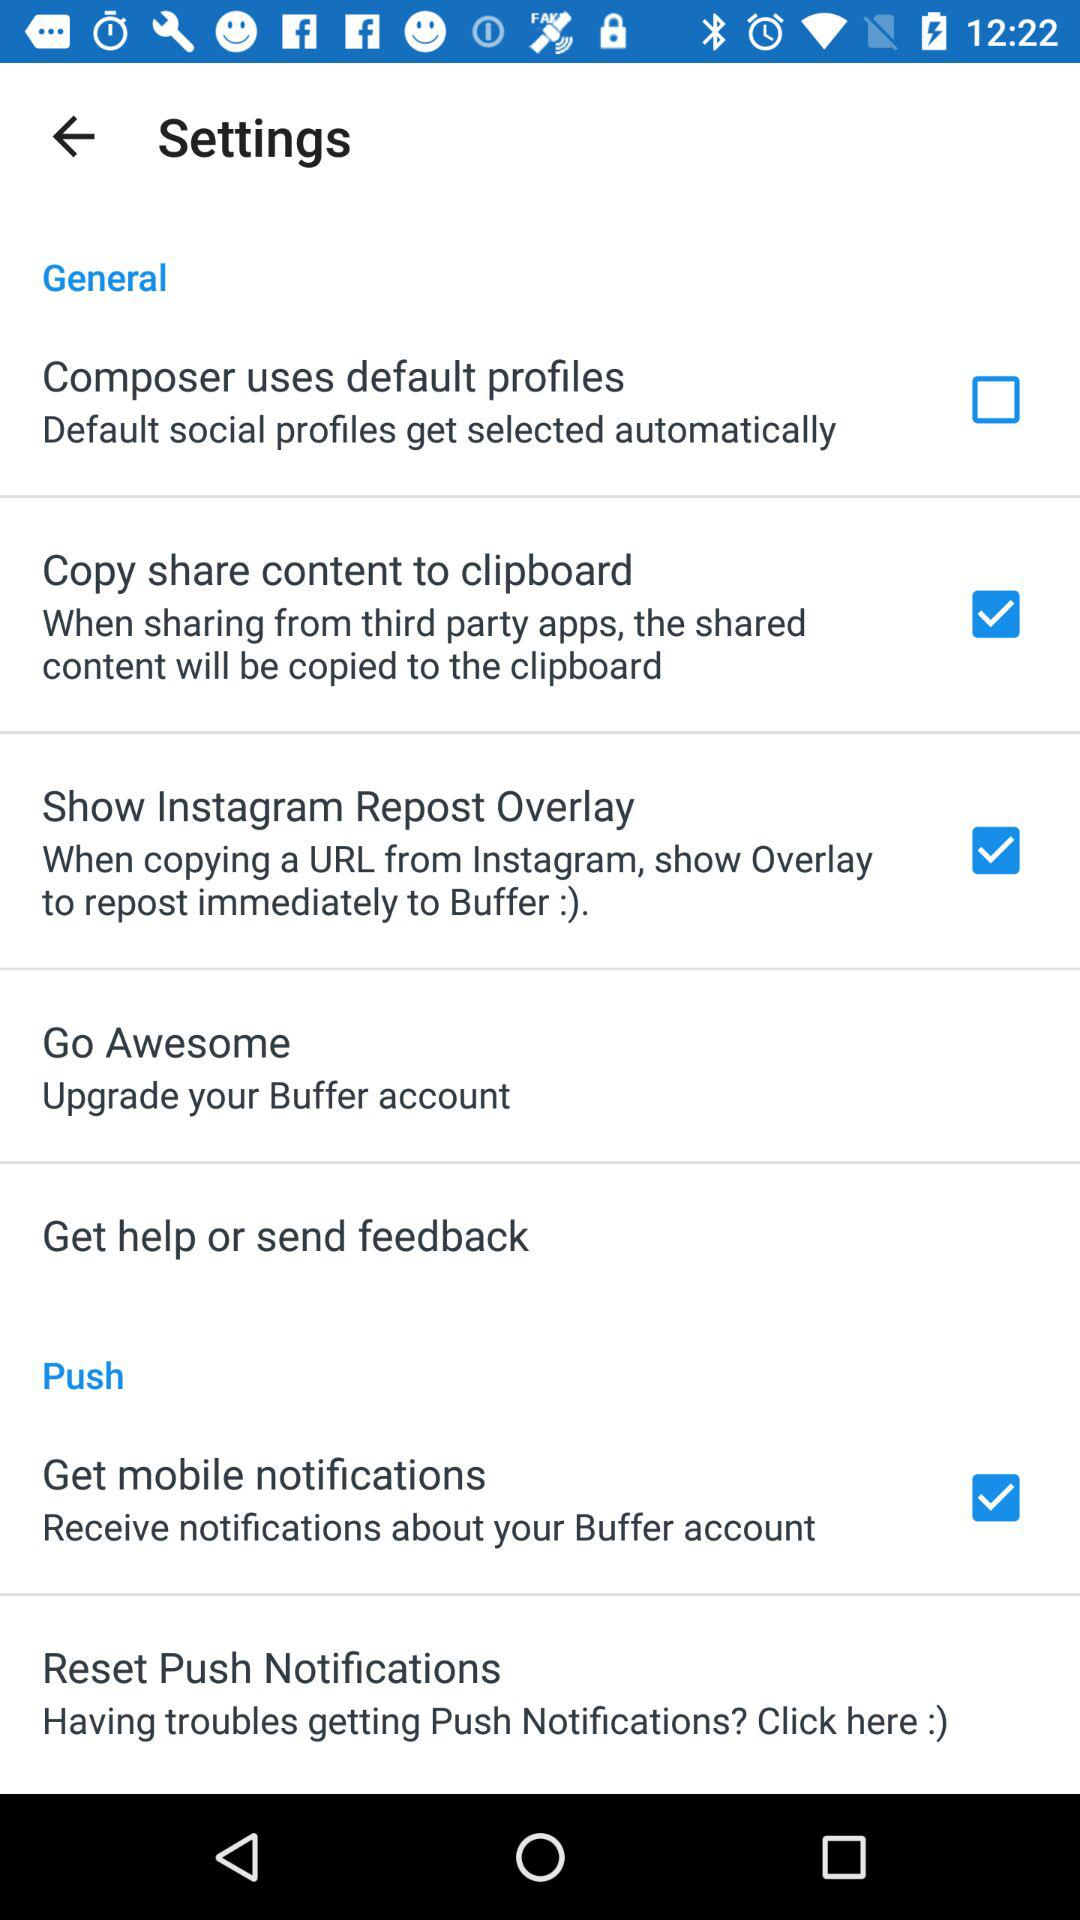How many items are there in the 'Push' settings section?
Answer the question using a single word or phrase. 2 